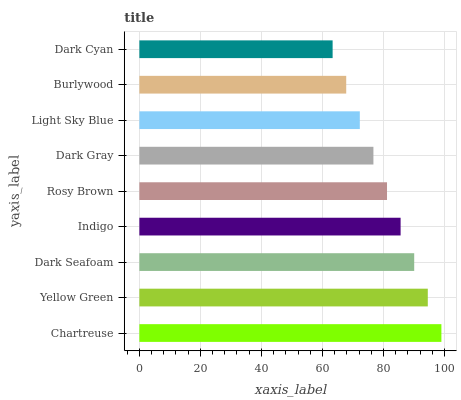Is Dark Cyan the minimum?
Answer yes or no. Yes. Is Chartreuse the maximum?
Answer yes or no. Yes. Is Yellow Green the minimum?
Answer yes or no. No. Is Yellow Green the maximum?
Answer yes or no. No. Is Chartreuse greater than Yellow Green?
Answer yes or no. Yes. Is Yellow Green less than Chartreuse?
Answer yes or no. Yes. Is Yellow Green greater than Chartreuse?
Answer yes or no. No. Is Chartreuse less than Yellow Green?
Answer yes or no. No. Is Rosy Brown the high median?
Answer yes or no. Yes. Is Rosy Brown the low median?
Answer yes or no. Yes. Is Light Sky Blue the high median?
Answer yes or no. No. Is Dark Seafoam the low median?
Answer yes or no. No. 